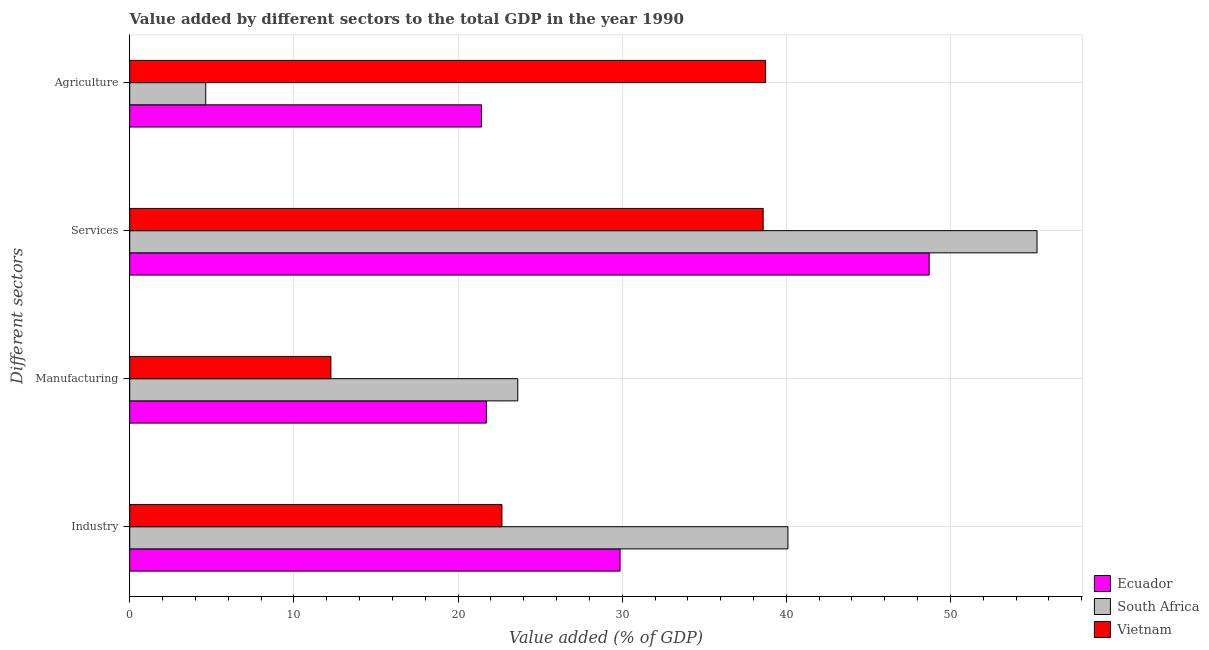How many different coloured bars are there?
Give a very brief answer. 3. How many groups of bars are there?
Offer a terse response. 4. Are the number of bars on each tick of the Y-axis equal?
Keep it short and to the point. Yes. What is the label of the 3rd group of bars from the top?
Keep it short and to the point. Manufacturing. What is the value added by industrial sector in South Africa?
Ensure brevity in your answer.  40.1. Across all countries, what is the maximum value added by agricultural sector?
Keep it short and to the point. 38.74. Across all countries, what is the minimum value added by agricultural sector?
Offer a terse response. 4.63. In which country was the value added by industrial sector maximum?
Provide a short and direct response. South Africa. In which country was the value added by agricultural sector minimum?
Make the answer very short. South Africa. What is the total value added by services sector in the graph?
Keep it short and to the point. 142.56. What is the difference between the value added by industrial sector in South Africa and that in Vietnam?
Offer a very short reply. 17.42. What is the difference between the value added by agricultural sector in Ecuador and the value added by industrial sector in South Africa?
Offer a terse response. -18.67. What is the average value added by manufacturing sector per country?
Ensure brevity in your answer.  19.21. What is the difference between the value added by manufacturing sector and value added by industrial sector in South Africa?
Your answer should be compact. -16.46. What is the ratio of the value added by manufacturing sector in Vietnam to that in South Africa?
Offer a very short reply. 0.52. Is the value added by agricultural sector in South Africa less than that in Vietnam?
Provide a succinct answer. Yes. What is the difference between the highest and the second highest value added by industrial sector?
Your answer should be very brief. 10.23. What is the difference between the highest and the lowest value added by agricultural sector?
Make the answer very short. 34.11. In how many countries, is the value added by services sector greater than the average value added by services sector taken over all countries?
Keep it short and to the point. 2. Is the sum of the value added by agricultural sector in South Africa and Ecuador greater than the maximum value added by industrial sector across all countries?
Keep it short and to the point. No. Is it the case that in every country, the sum of the value added by agricultural sector and value added by services sector is greater than the sum of value added by manufacturing sector and value added by industrial sector?
Offer a terse response. No. What does the 2nd bar from the top in Services represents?
Make the answer very short. South Africa. What does the 3rd bar from the bottom in Services represents?
Keep it short and to the point. Vietnam. Is it the case that in every country, the sum of the value added by industrial sector and value added by manufacturing sector is greater than the value added by services sector?
Provide a succinct answer. No. How many bars are there?
Your answer should be compact. 12. Are all the bars in the graph horizontal?
Offer a very short reply. Yes. What is the difference between two consecutive major ticks on the X-axis?
Give a very brief answer. 10. Does the graph contain any zero values?
Provide a succinct answer. No. Where does the legend appear in the graph?
Your answer should be compact. Bottom right. How are the legend labels stacked?
Your answer should be compact. Vertical. What is the title of the graph?
Keep it short and to the point. Value added by different sectors to the total GDP in the year 1990. Does "Antigua and Barbuda" appear as one of the legend labels in the graph?
Provide a short and direct response. No. What is the label or title of the X-axis?
Offer a very short reply. Value added (% of GDP). What is the label or title of the Y-axis?
Your answer should be compact. Different sectors. What is the Value added (% of GDP) in Ecuador in Industry?
Provide a succinct answer. 29.87. What is the Value added (% of GDP) of South Africa in Industry?
Ensure brevity in your answer.  40.1. What is the Value added (% of GDP) of Vietnam in Industry?
Provide a succinct answer. 22.67. What is the Value added (% of GDP) of Ecuador in Manufacturing?
Provide a short and direct response. 21.73. What is the Value added (% of GDP) in South Africa in Manufacturing?
Keep it short and to the point. 23.64. What is the Value added (% of GDP) of Vietnam in Manufacturing?
Give a very brief answer. 12.26. What is the Value added (% of GDP) of Ecuador in Services?
Make the answer very short. 48.7. What is the Value added (% of GDP) in South Africa in Services?
Provide a succinct answer. 55.27. What is the Value added (% of GDP) of Vietnam in Services?
Keep it short and to the point. 38.59. What is the Value added (% of GDP) of Ecuador in Agriculture?
Make the answer very short. 21.43. What is the Value added (% of GDP) in South Africa in Agriculture?
Your response must be concise. 4.63. What is the Value added (% of GDP) of Vietnam in Agriculture?
Your response must be concise. 38.74. Across all Different sectors, what is the maximum Value added (% of GDP) of Ecuador?
Your answer should be very brief. 48.7. Across all Different sectors, what is the maximum Value added (% of GDP) of South Africa?
Keep it short and to the point. 55.27. Across all Different sectors, what is the maximum Value added (% of GDP) in Vietnam?
Your response must be concise. 38.74. Across all Different sectors, what is the minimum Value added (% of GDP) in Ecuador?
Offer a very short reply. 21.43. Across all Different sectors, what is the minimum Value added (% of GDP) in South Africa?
Your answer should be very brief. 4.63. Across all Different sectors, what is the minimum Value added (% of GDP) in Vietnam?
Your answer should be compact. 12.26. What is the total Value added (% of GDP) of Ecuador in the graph?
Provide a short and direct response. 121.73. What is the total Value added (% of GDP) in South Africa in the graph?
Your answer should be very brief. 123.64. What is the total Value added (% of GDP) in Vietnam in the graph?
Provide a short and direct response. 112.26. What is the difference between the Value added (% of GDP) of Ecuador in Industry and that in Manufacturing?
Your answer should be very brief. 8.14. What is the difference between the Value added (% of GDP) of South Africa in Industry and that in Manufacturing?
Give a very brief answer. 16.46. What is the difference between the Value added (% of GDP) of Vietnam in Industry and that in Manufacturing?
Offer a terse response. 10.42. What is the difference between the Value added (% of GDP) in Ecuador in Industry and that in Services?
Offer a very short reply. -18.83. What is the difference between the Value added (% of GDP) of South Africa in Industry and that in Services?
Make the answer very short. -15.18. What is the difference between the Value added (% of GDP) of Vietnam in Industry and that in Services?
Provide a succinct answer. -15.91. What is the difference between the Value added (% of GDP) in Ecuador in Industry and that in Agriculture?
Offer a terse response. 8.44. What is the difference between the Value added (% of GDP) in South Africa in Industry and that in Agriculture?
Provide a succinct answer. 35.47. What is the difference between the Value added (% of GDP) of Vietnam in Industry and that in Agriculture?
Give a very brief answer. -16.06. What is the difference between the Value added (% of GDP) of Ecuador in Manufacturing and that in Services?
Offer a very short reply. -26.97. What is the difference between the Value added (% of GDP) in South Africa in Manufacturing and that in Services?
Make the answer very short. -31.63. What is the difference between the Value added (% of GDP) of Vietnam in Manufacturing and that in Services?
Keep it short and to the point. -26.33. What is the difference between the Value added (% of GDP) of Ecuador in Manufacturing and that in Agriculture?
Keep it short and to the point. 0.3. What is the difference between the Value added (% of GDP) in South Africa in Manufacturing and that in Agriculture?
Provide a succinct answer. 19.01. What is the difference between the Value added (% of GDP) in Vietnam in Manufacturing and that in Agriculture?
Your response must be concise. -26.48. What is the difference between the Value added (% of GDP) in Ecuador in Services and that in Agriculture?
Offer a very short reply. 27.27. What is the difference between the Value added (% of GDP) of South Africa in Services and that in Agriculture?
Give a very brief answer. 50.64. What is the difference between the Value added (% of GDP) of Vietnam in Services and that in Agriculture?
Offer a terse response. -0.15. What is the difference between the Value added (% of GDP) of Ecuador in Industry and the Value added (% of GDP) of South Africa in Manufacturing?
Your response must be concise. 6.23. What is the difference between the Value added (% of GDP) of Ecuador in Industry and the Value added (% of GDP) of Vietnam in Manufacturing?
Offer a terse response. 17.62. What is the difference between the Value added (% of GDP) of South Africa in Industry and the Value added (% of GDP) of Vietnam in Manufacturing?
Make the answer very short. 27.84. What is the difference between the Value added (% of GDP) in Ecuador in Industry and the Value added (% of GDP) in South Africa in Services?
Give a very brief answer. -25.4. What is the difference between the Value added (% of GDP) in Ecuador in Industry and the Value added (% of GDP) in Vietnam in Services?
Your answer should be very brief. -8.72. What is the difference between the Value added (% of GDP) in South Africa in Industry and the Value added (% of GDP) in Vietnam in Services?
Ensure brevity in your answer.  1.51. What is the difference between the Value added (% of GDP) of Ecuador in Industry and the Value added (% of GDP) of South Africa in Agriculture?
Your answer should be compact. 25.24. What is the difference between the Value added (% of GDP) in Ecuador in Industry and the Value added (% of GDP) in Vietnam in Agriculture?
Give a very brief answer. -8.87. What is the difference between the Value added (% of GDP) in South Africa in Industry and the Value added (% of GDP) in Vietnam in Agriculture?
Provide a succinct answer. 1.36. What is the difference between the Value added (% of GDP) of Ecuador in Manufacturing and the Value added (% of GDP) of South Africa in Services?
Make the answer very short. -33.54. What is the difference between the Value added (% of GDP) of Ecuador in Manufacturing and the Value added (% of GDP) of Vietnam in Services?
Keep it short and to the point. -16.86. What is the difference between the Value added (% of GDP) in South Africa in Manufacturing and the Value added (% of GDP) in Vietnam in Services?
Your answer should be very brief. -14.95. What is the difference between the Value added (% of GDP) in Ecuador in Manufacturing and the Value added (% of GDP) in South Africa in Agriculture?
Make the answer very short. 17.1. What is the difference between the Value added (% of GDP) in Ecuador in Manufacturing and the Value added (% of GDP) in Vietnam in Agriculture?
Make the answer very short. -17.01. What is the difference between the Value added (% of GDP) of South Africa in Manufacturing and the Value added (% of GDP) of Vietnam in Agriculture?
Your response must be concise. -15.1. What is the difference between the Value added (% of GDP) of Ecuador in Services and the Value added (% of GDP) of South Africa in Agriculture?
Your answer should be very brief. 44.07. What is the difference between the Value added (% of GDP) of Ecuador in Services and the Value added (% of GDP) of Vietnam in Agriculture?
Offer a very short reply. 9.96. What is the difference between the Value added (% of GDP) of South Africa in Services and the Value added (% of GDP) of Vietnam in Agriculture?
Your response must be concise. 16.54. What is the average Value added (% of GDP) of Ecuador per Different sectors?
Provide a short and direct response. 30.43. What is the average Value added (% of GDP) of South Africa per Different sectors?
Ensure brevity in your answer.  30.91. What is the average Value added (% of GDP) in Vietnam per Different sectors?
Your answer should be very brief. 28.06. What is the difference between the Value added (% of GDP) in Ecuador and Value added (% of GDP) in South Africa in Industry?
Make the answer very short. -10.23. What is the difference between the Value added (% of GDP) of Ecuador and Value added (% of GDP) of Vietnam in Industry?
Provide a short and direct response. 7.2. What is the difference between the Value added (% of GDP) of South Africa and Value added (% of GDP) of Vietnam in Industry?
Your answer should be very brief. 17.42. What is the difference between the Value added (% of GDP) of Ecuador and Value added (% of GDP) of South Africa in Manufacturing?
Ensure brevity in your answer.  -1.91. What is the difference between the Value added (% of GDP) in Ecuador and Value added (% of GDP) in Vietnam in Manufacturing?
Give a very brief answer. 9.47. What is the difference between the Value added (% of GDP) of South Africa and Value added (% of GDP) of Vietnam in Manufacturing?
Ensure brevity in your answer.  11.38. What is the difference between the Value added (% of GDP) in Ecuador and Value added (% of GDP) in South Africa in Services?
Offer a very short reply. -6.57. What is the difference between the Value added (% of GDP) of Ecuador and Value added (% of GDP) of Vietnam in Services?
Offer a very short reply. 10.11. What is the difference between the Value added (% of GDP) of South Africa and Value added (% of GDP) of Vietnam in Services?
Your answer should be compact. 16.68. What is the difference between the Value added (% of GDP) of Ecuador and Value added (% of GDP) of South Africa in Agriculture?
Give a very brief answer. 16.8. What is the difference between the Value added (% of GDP) of Ecuador and Value added (% of GDP) of Vietnam in Agriculture?
Ensure brevity in your answer.  -17.31. What is the difference between the Value added (% of GDP) in South Africa and Value added (% of GDP) in Vietnam in Agriculture?
Give a very brief answer. -34.11. What is the ratio of the Value added (% of GDP) of Ecuador in Industry to that in Manufacturing?
Keep it short and to the point. 1.37. What is the ratio of the Value added (% of GDP) of South Africa in Industry to that in Manufacturing?
Provide a succinct answer. 1.7. What is the ratio of the Value added (% of GDP) in Vietnam in Industry to that in Manufacturing?
Keep it short and to the point. 1.85. What is the ratio of the Value added (% of GDP) of Ecuador in Industry to that in Services?
Offer a very short reply. 0.61. What is the ratio of the Value added (% of GDP) in South Africa in Industry to that in Services?
Provide a succinct answer. 0.73. What is the ratio of the Value added (% of GDP) of Vietnam in Industry to that in Services?
Your response must be concise. 0.59. What is the ratio of the Value added (% of GDP) of Ecuador in Industry to that in Agriculture?
Your answer should be compact. 1.39. What is the ratio of the Value added (% of GDP) of South Africa in Industry to that in Agriculture?
Ensure brevity in your answer.  8.66. What is the ratio of the Value added (% of GDP) of Vietnam in Industry to that in Agriculture?
Keep it short and to the point. 0.59. What is the ratio of the Value added (% of GDP) of Ecuador in Manufacturing to that in Services?
Ensure brevity in your answer.  0.45. What is the ratio of the Value added (% of GDP) in South Africa in Manufacturing to that in Services?
Give a very brief answer. 0.43. What is the ratio of the Value added (% of GDP) of Vietnam in Manufacturing to that in Services?
Offer a very short reply. 0.32. What is the ratio of the Value added (% of GDP) of Ecuador in Manufacturing to that in Agriculture?
Give a very brief answer. 1.01. What is the ratio of the Value added (% of GDP) in South Africa in Manufacturing to that in Agriculture?
Provide a succinct answer. 5.11. What is the ratio of the Value added (% of GDP) of Vietnam in Manufacturing to that in Agriculture?
Ensure brevity in your answer.  0.32. What is the ratio of the Value added (% of GDP) in Ecuador in Services to that in Agriculture?
Offer a terse response. 2.27. What is the ratio of the Value added (% of GDP) of South Africa in Services to that in Agriculture?
Make the answer very short. 11.94. What is the difference between the highest and the second highest Value added (% of GDP) in Ecuador?
Give a very brief answer. 18.83. What is the difference between the highest and the second highest Value added (% of GDP) of South Africa?
Make the answer very short. 15.18. What is the difference between the highest and the second highest Value added (% of GDP) in Vietnam?
Your response must be concise. 0.15. What is the difference between the highest and the lowest Value added (% of GDP) in Ecuador?
Your answer should be compact. 27.27. What is the difference between the highest and the lowest Value added (% of GDP) of South Africa?
Give a very brief answer. 50.64. What is the difference between the highest and the lowest Value added (% of GDP) in Vietnam?
Make the answer very short. 26.48. 